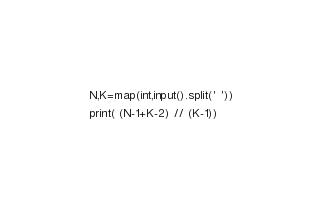<code> <loc_0><loc_0><loc_500><loc_500><_Python_>N,K=map(int,input().split(' '))
print( (N-1+K-2) // (K-1))</code> 